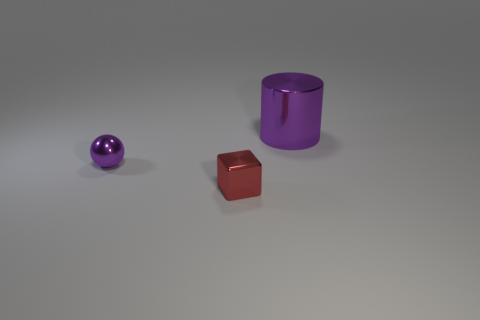Subtract all purple blocks. Subtract all cyan cylinders. How many blocks are left? 1 Add 2 big cylinders. How many objects exist? 5 Subtract all balls. How many objects are left? 2 Subtract all big cyan objects. Subtract all big purple cylinders. How many objects are left? 2 Add 1 red objects. How many red objects are left? 2 Add 1 tiny purple metal spheres. How many tiny purple metal spheres exist? 2 Subtract 0 blue cylinders. How many objects are left? 3 